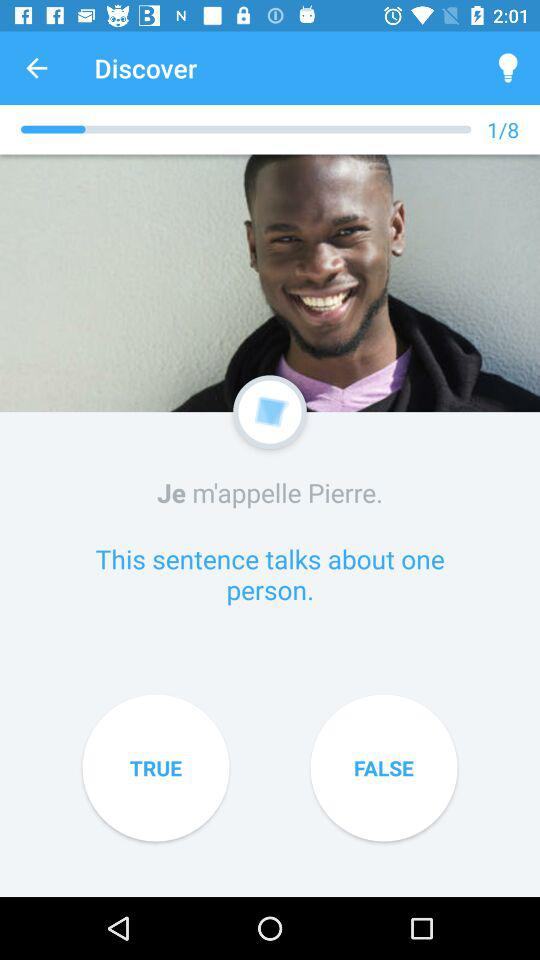What question number am I asking? The question number is 1. 